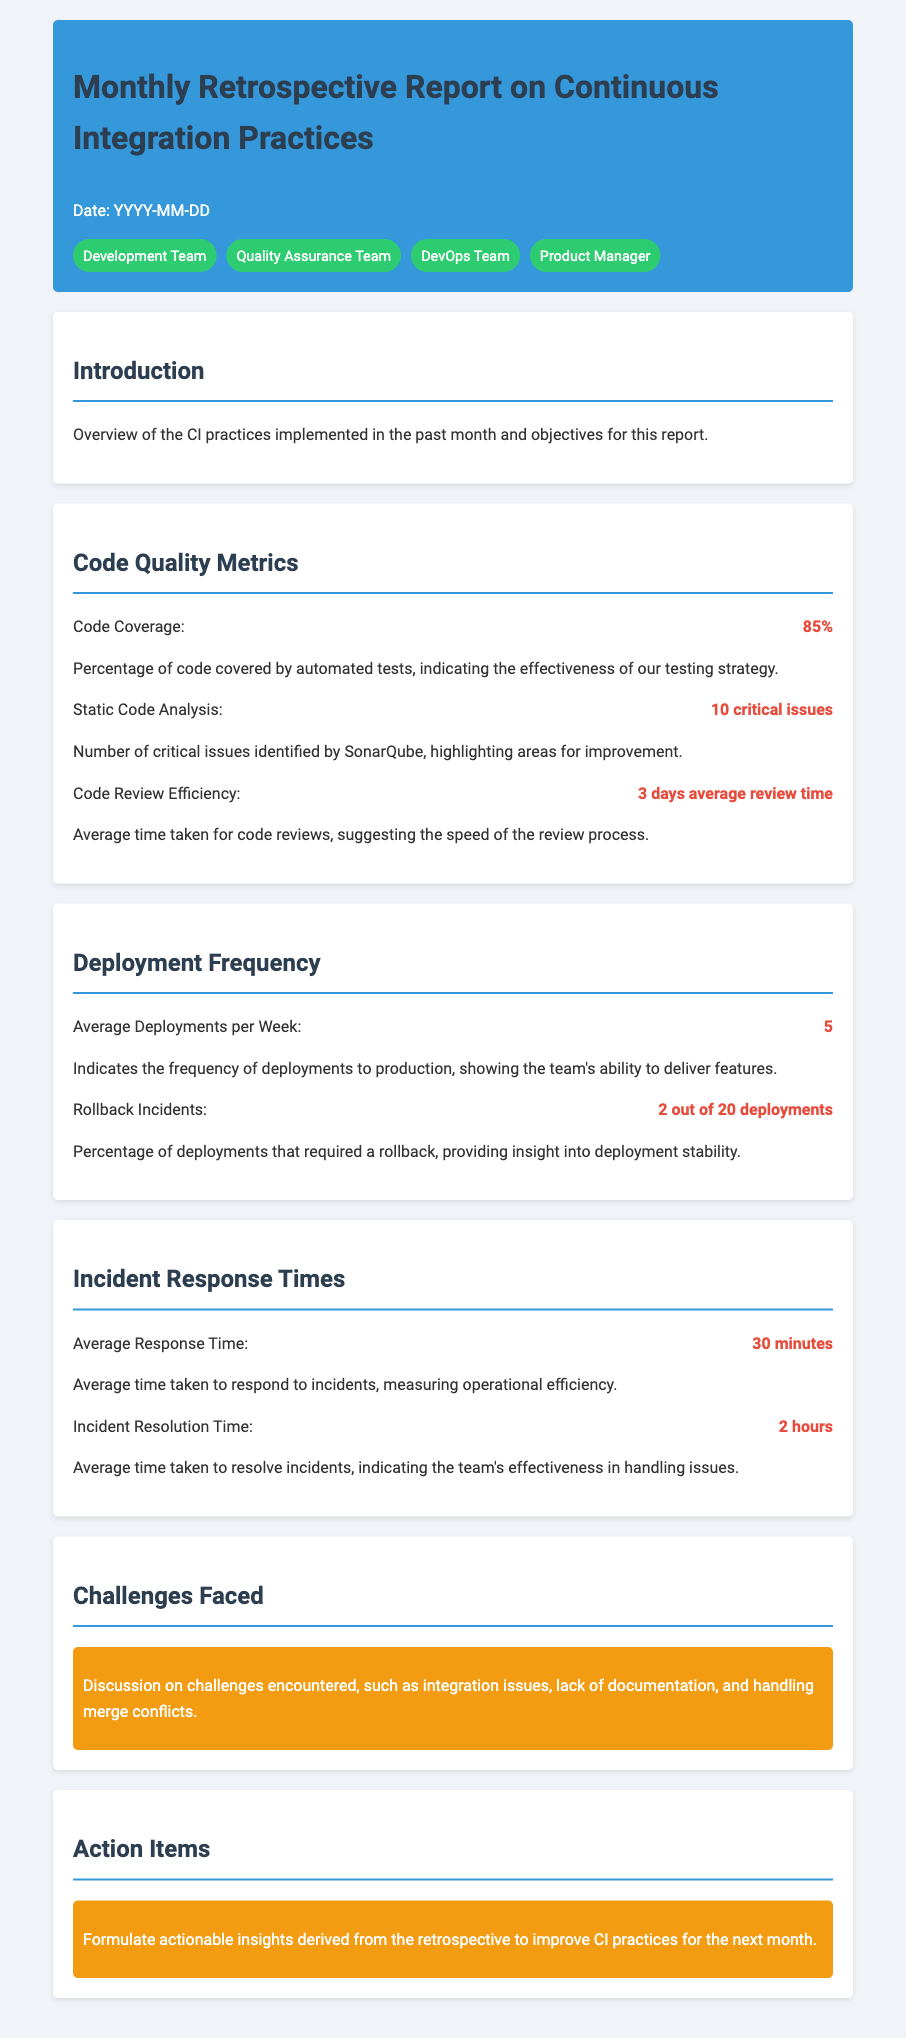What is the date of the report? The date listed in the document is represented as 'YYYY-MM-DD', indicating a placeholder for the actual date.
Answer: YYYY-MM-DD What is the code coverage percentage? The document states that the code coverage is at 85%, indicating the percentage of code covered by automated tests.
Answer: 85% How many average deployments occur per week? According to the deployment frequency section, the average number of deployments per week is noted as 5.
Answer: 5 What is the average incident response time? The average response time mentioned in the incident response times section is 30 minutes.
Answer: 30 minutes How many critical issues were identified by static code analysis? The document mentions that 10 critical issues were identified by SonarQube, highlighting areas for improvement.
Answer: 10 critical issues What percentage of deployments required a rollback? The rollback incidents section states that 2 out of 20 deployments required a rollback, which can be interpreted as a 10% rollback rate.
Answer: 2 out of 20 What is the average time taken for incident resolution? According to the document, the average incident resolution time is listed as 2 hours.
Answer: 2 hours What are the stated challenges faced during the month? The document mentions challenges such as integration issues, lack of documentation, and handling merge conflicts.
Answer: Integration issues, lack of documentation, handling merge conflicts What actionable insights are mentioned in the action items? The document states to formulate actionable insights derived from the retrospective to improve CI practices for the next month.
Answer: Formulate actionable insights 